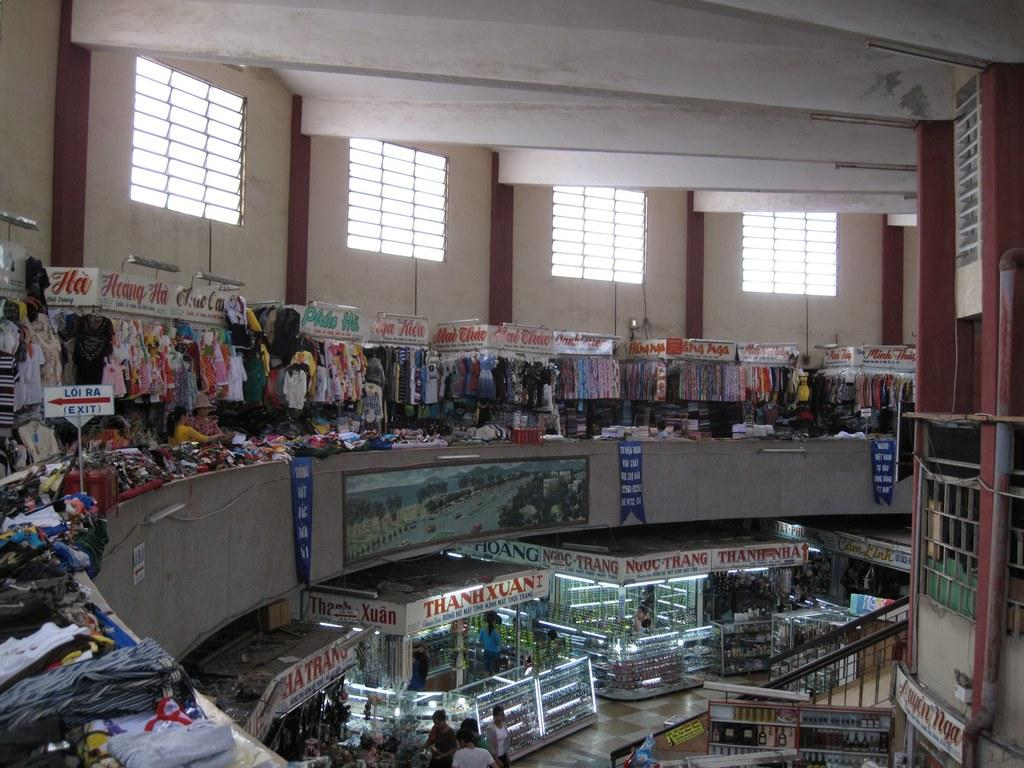<image>
Present a compact description of the photo's key features. Inside a clothing market area with a long sign that says THANHXUAI 